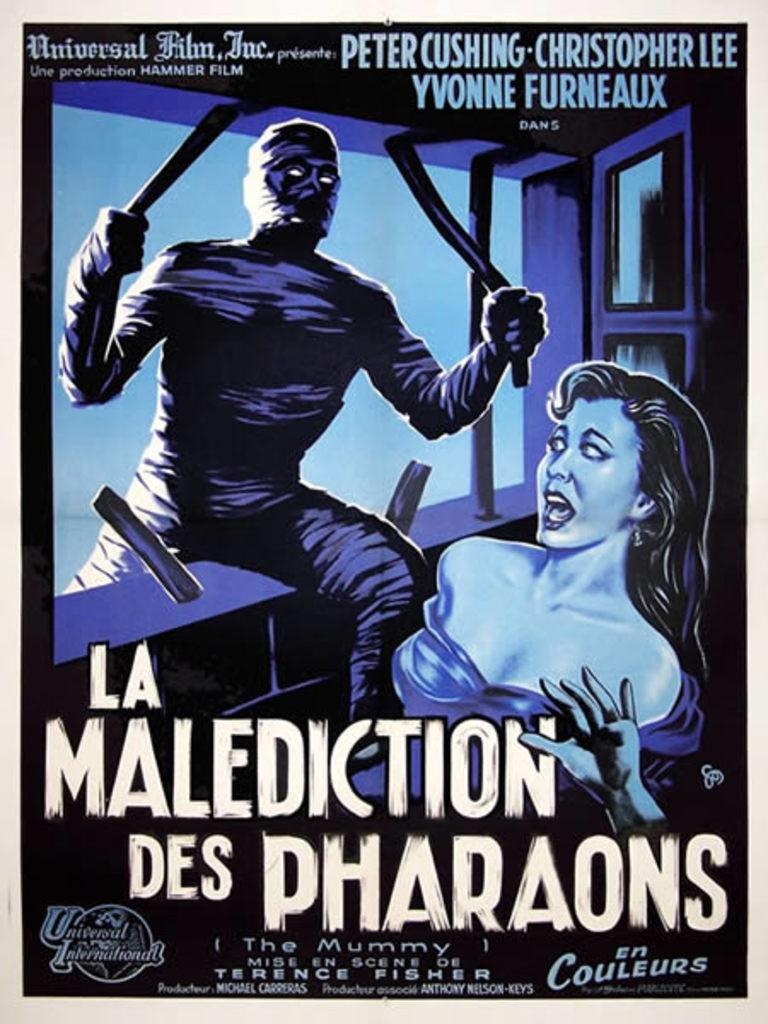<image>
Present a compact description of the photo's key features. Poster for a movie titled La Malediction Des Pharaons". 